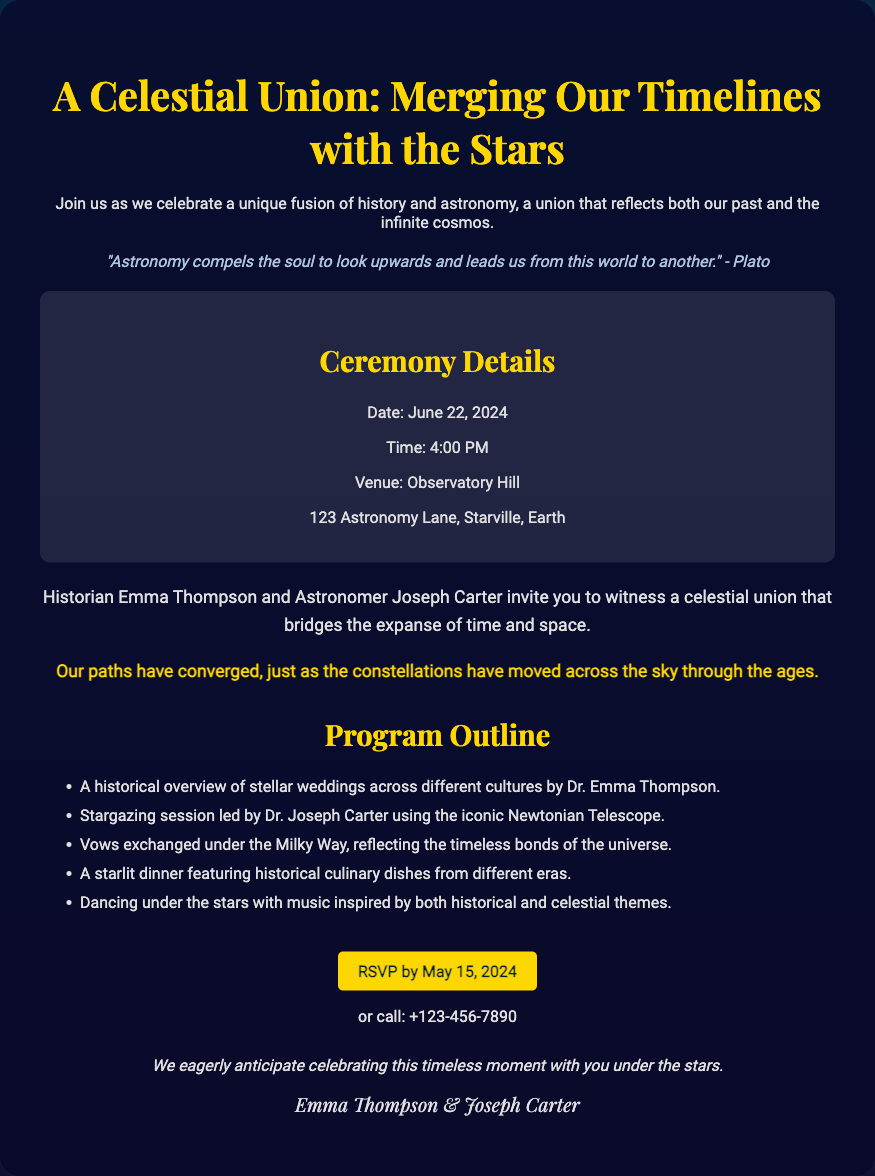What is the date of the wedding? The wedding date is explicitly mentioned in the ceremony details section of the document.
Answer: June 22, 2024 What is the venue for the wedding? The venue is specified in the ceremony details, providing a clear location for the event.
Answer: Observatory Hill Who is marrying Joseph? The document states the names of the couple getting married.
Answer: Emma Thompson What is a unique theme mentioned in the invitation? The document highlights the merging of themes related to history and astronomy in the wedding.
Answer: Celestial Union What type of session is included in the program? One of the activities detailed in the program outline highlights star-related activities.
Answer: Stargazing session What culinary focus will the dinner have? The program mentions a specific aspect of the dinner related to different eras.
Answer: Historical culinary dishes What quote is included in the invitation? A philosophical quote is cited to reflect the theme of the event.
Answer: "Astronomy compels the soul to look upwards and leads us from this world to another." - Plato What is the RSVP deadline? The invitation specifies a cutoff date for RSVPs in the contact information section.
Answer: May 15, 2024 